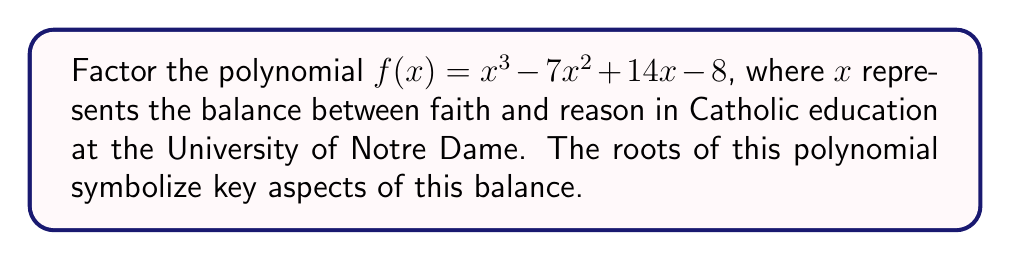Can you answer this question? Let's approach this step-by-step:

1) First, we can check if there are any rational roots using the rational root theorem. The possible rational roots are the factors of the constant term: ±1, ±2, ±4, ±8.

2) Testing these values, we find that $f(1) = 0$. So $(x-1)$ is a factor.

3) We can use polynomial long division to divide $f(x)$ by $(x-1)$:

   $x^3 - 7x^2 + 14x - 8 = (x-1)(x^2 - 6x + 8)$

4) Now we need to factor the quadratic $x^2 - 6x + 8$. We can do this by finding two numbers that multiply to give 8 and add to give -6.

5) These numbers are -2 and -4.

6) Therefore, $x^2 - 6x + 8 = (x-2)(x-4)$

7) Putting it all together:

   $f(x) = (x-1)(x-2)(x-4)$

In the context of Catholic education at Notre Dame, these factors could represent:
(x-1): Unity of faith and reason
(x-2): Dual nature of intellectual and spiritual growth
(x-4): Quadrivium of Catholic education (representing the four classical liberal arts)
Answer: $(x-1)(x-2)(x-4)$ 